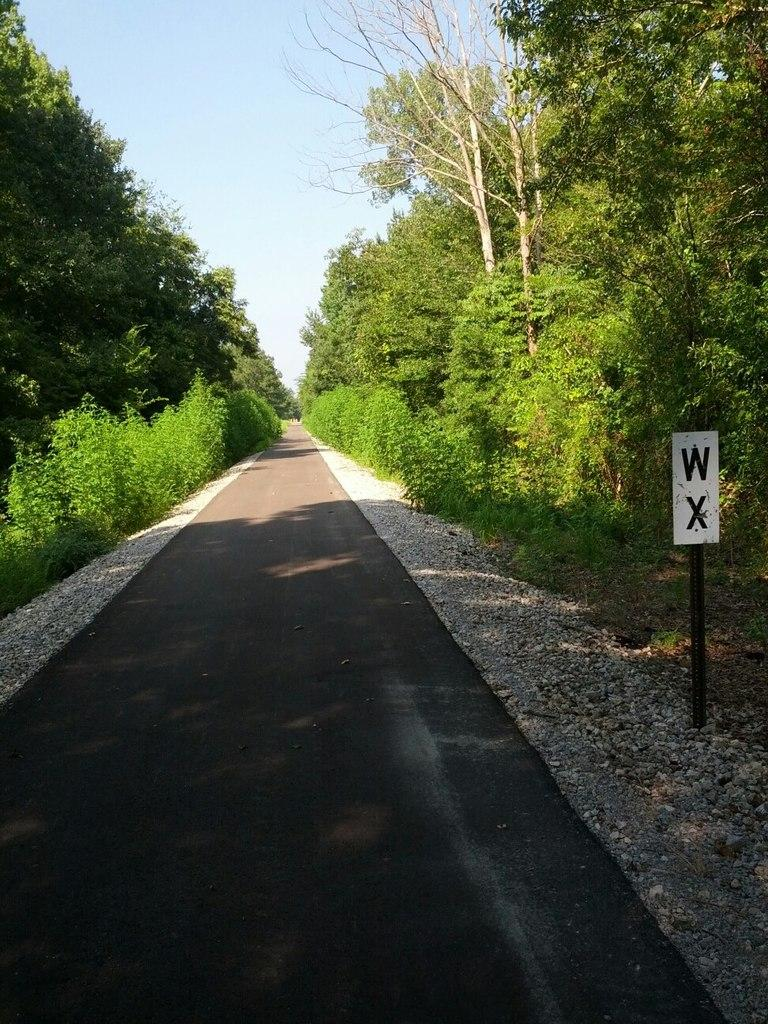What is the main feature of the image? There is a road in the image. What can be seen alongside the road? Trees and plants are present alongside the road. What is located on the right side of the image? There is a sign board on the right side of the image. What is visible at the top of the image? The sky is visible at the top of the image. How many pets are visible in the image? There are no pets present in the image. What type of cast is visible on the grandmother's leg in the image? There is no grandmother or cast present in the image. 